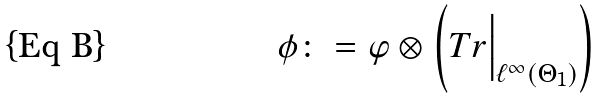Convert formula to latex. <formula><loc_0><loc_0><loc_500><loc_500>\phi \colon = \varphi \otimes \left ( T r \Big | _ { \ell ^ { \infty } \left ( \Theta _ { 1 } \right ) } \right )</formula> 